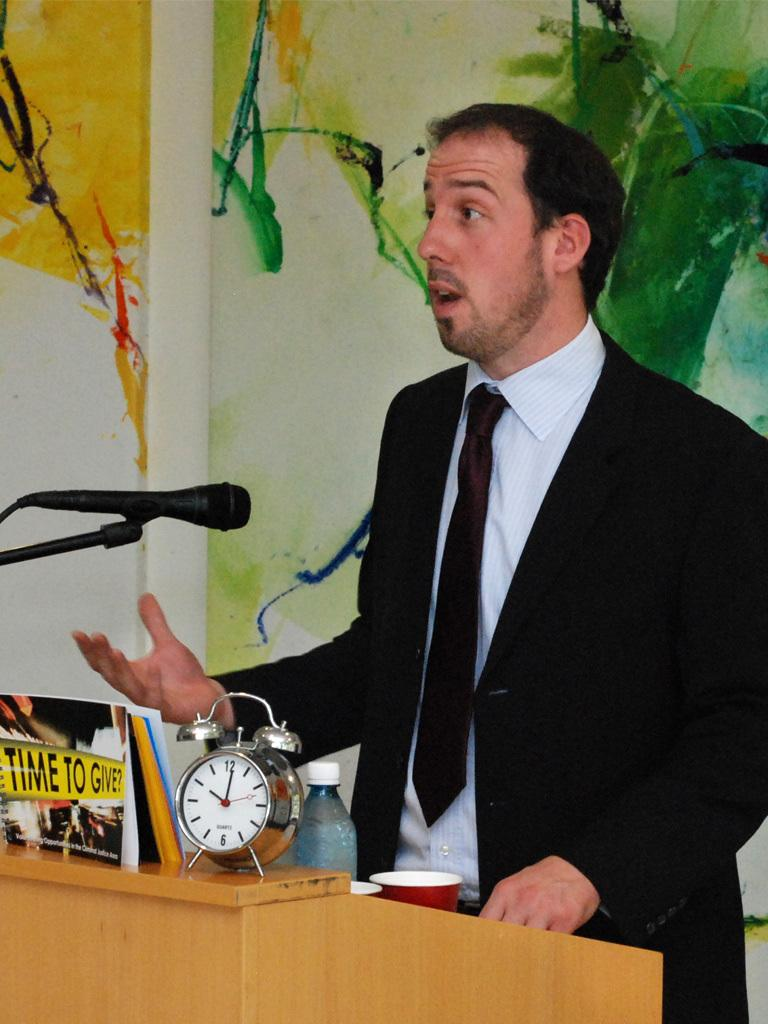<image>
Give a short and clear explanation of the subsequent image. A man in front of a podium with a Time to Give sign on it. 